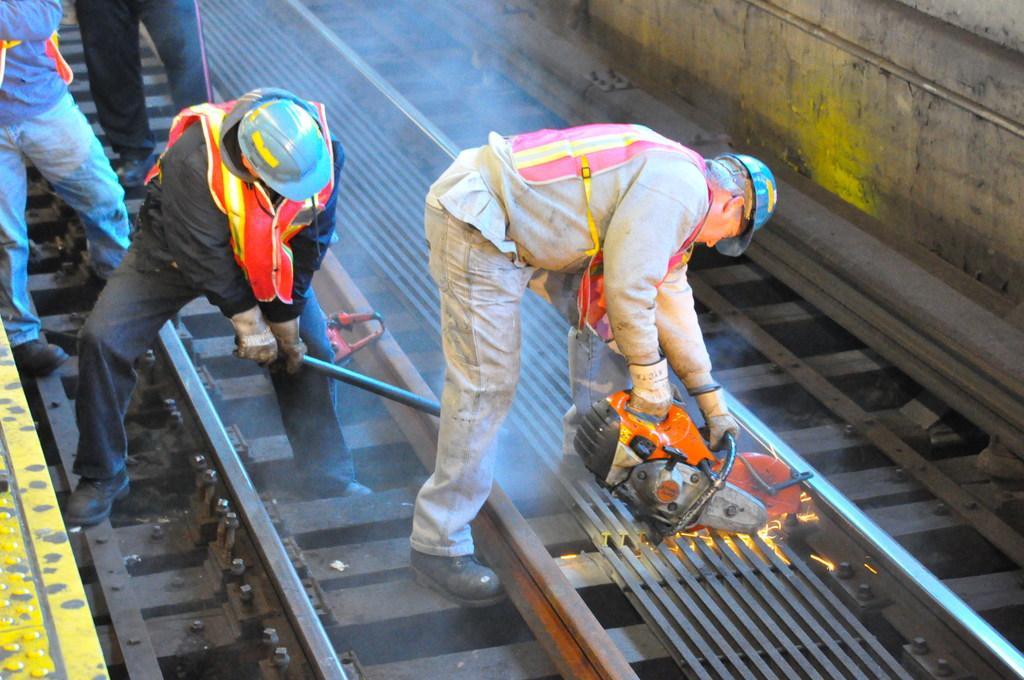Please provide a concise description of this image. This image consists of four men. On the right, the man is holding a cutting machine. And he is cutting the metal. In the middle, the man is holding a rod. At the bottom, there are tracks. On the right, there is a wall. 